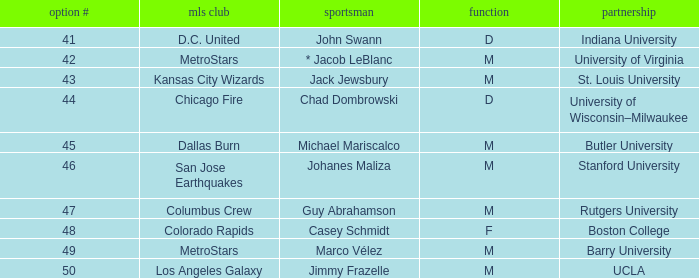Could you parse the entire table? {'header': ['option #', 'mls club', 'sportsman', 'function', 'partnership'], 'rows': [['41', 'D.C. United', 'John Swann', 'D', 'Indiana University'], ['42', 'MetroStars', '* Jacob LeBlanc', 'M', 'University of Virginia'], ['43', 'Kansas City Wizards', 'Jack Jewsbury', 'M', 'St. Louis University'], ['44', 'Chicago Fire', 'Chad Dombrowski', 'D', 'University of Wisconsin–Milwaukee'], ['45', 'Dallas Burn', 'Michael Mariscalco', 'M', 'Butler University'], ['46', 'San Jose Earthquakes', 'Johanes Maliza', 'M', 'Stanford University'], ['47', 'Columbus Crew', 'Guy Abrahamson', 'M', 'Rutgers University'], ['48', 'Colorado Rapids', 'Casey Schmidt', 'F', 'Boston College'], ['49', 'MetroStars', 'Marco Vélez', 'M', 'Barry University'], ['50', 'Los Angeles Galaxy', 'Jimmy Frazelle', 'M', 'UCLA']]} What position has UCLA pick that is larger than #47? M. 